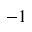<formula> <loc_0><loc_0><loc_500><loc_500>- 1</formula> 